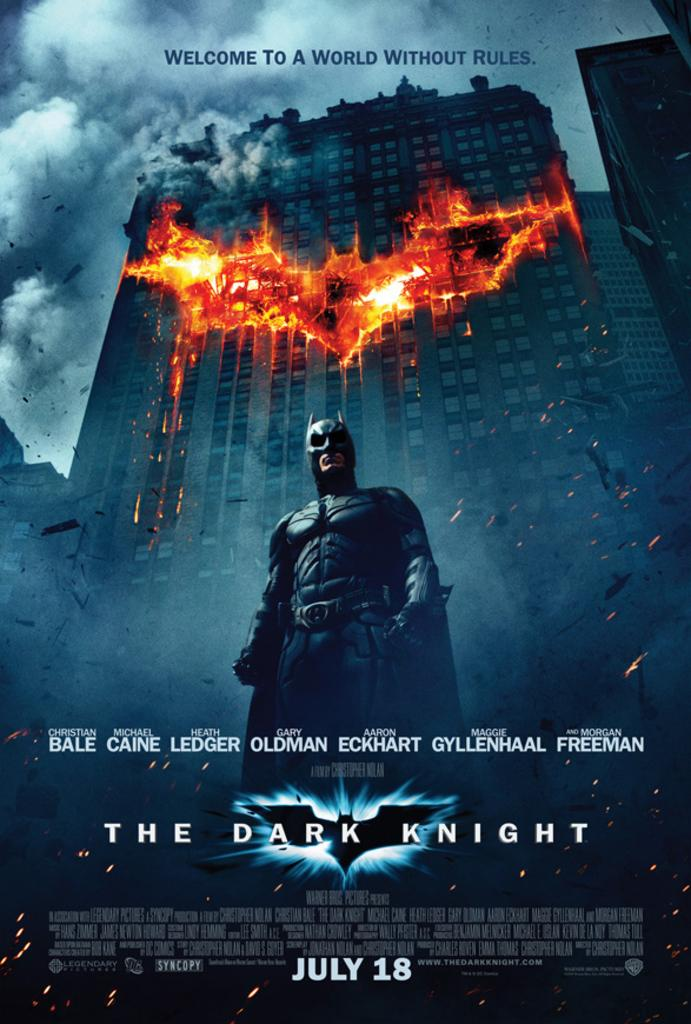<image>
Give a short and clear explanation of the subsequent image. a poster the reads Welcome to a World without rules 